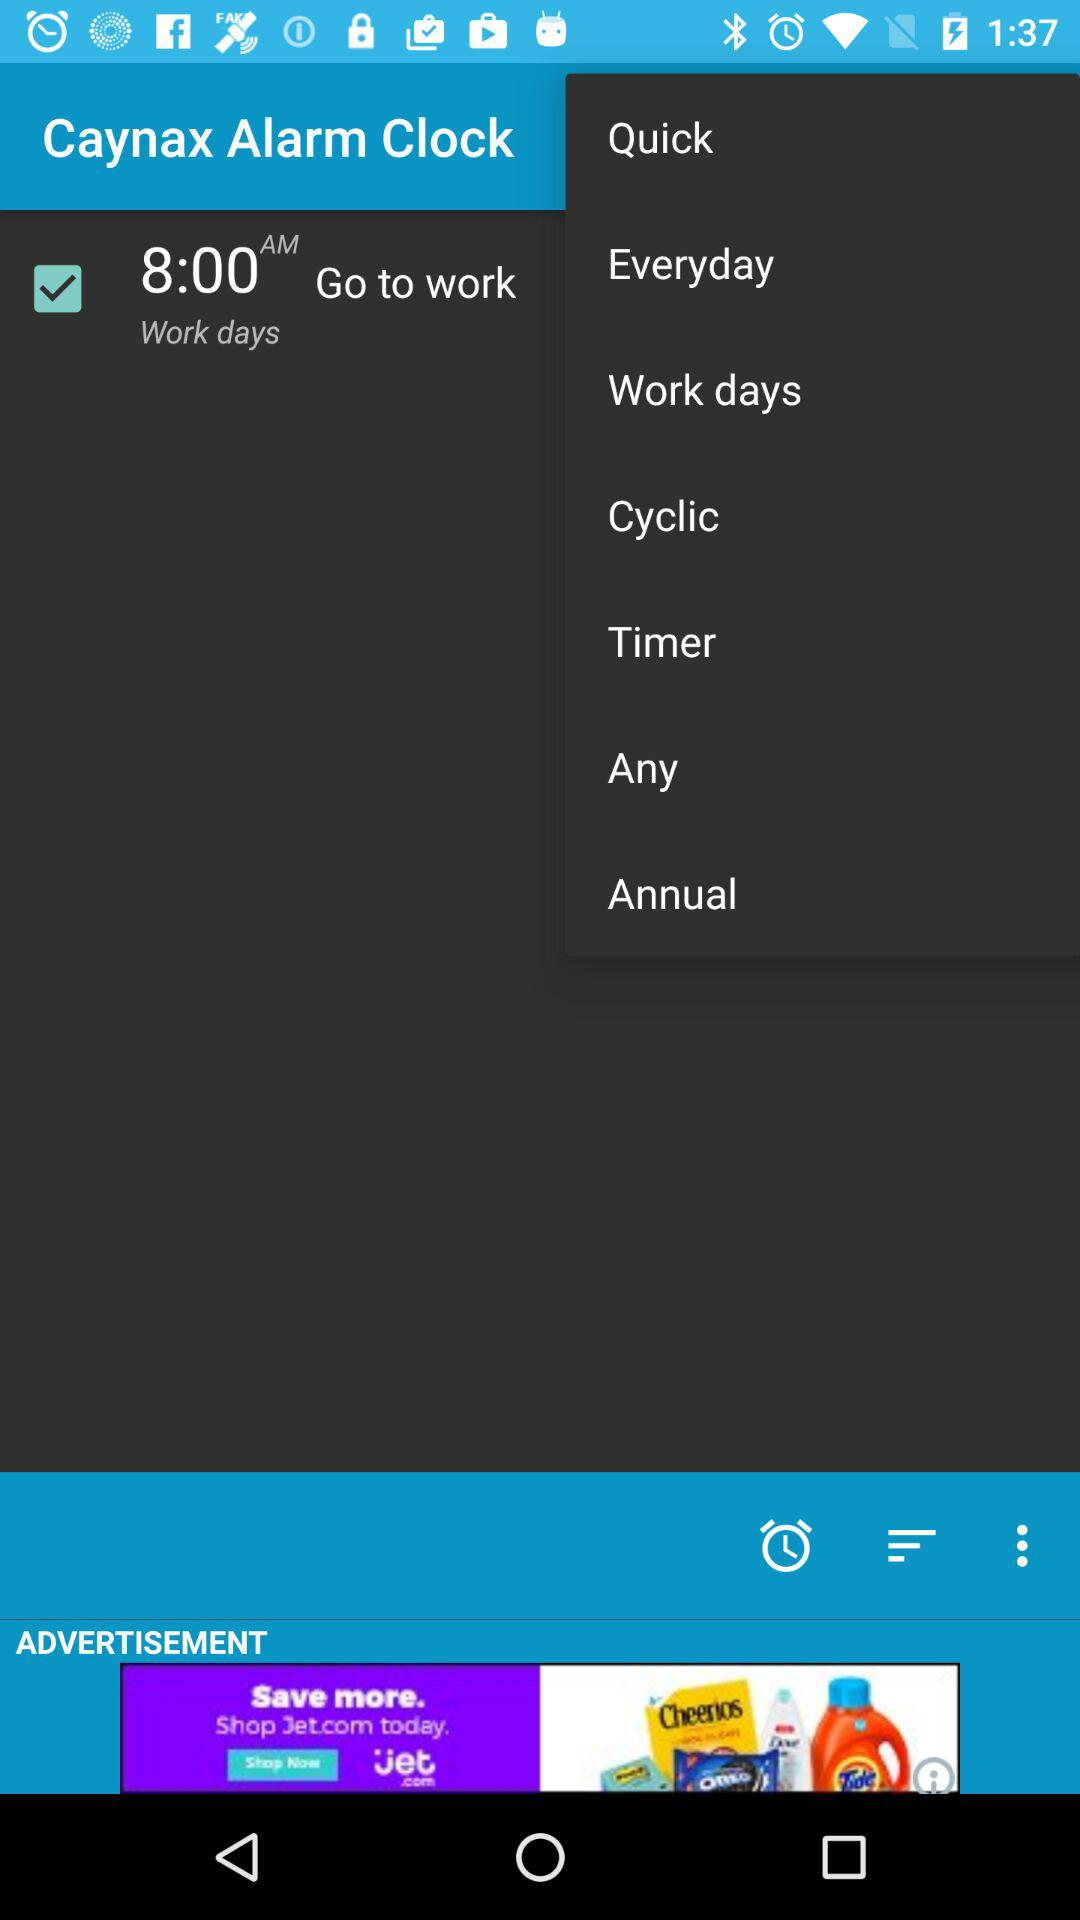What is the app name? The app name is "Caynax Alarm Clock". 